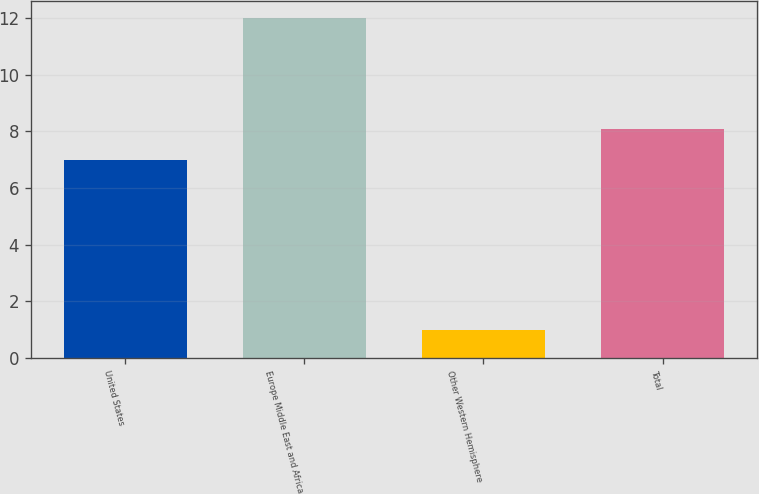<chart> <loc_0><loc_0><loc_500><loc_500><bar_chart><fcel>United States<fcel>Europe Middle East and Africa<fcel>Other Western Hemisphere<fcel>Total<nl><fcel>7<fcel>12<fcel>1<fcel>8.1<nl></chart> 